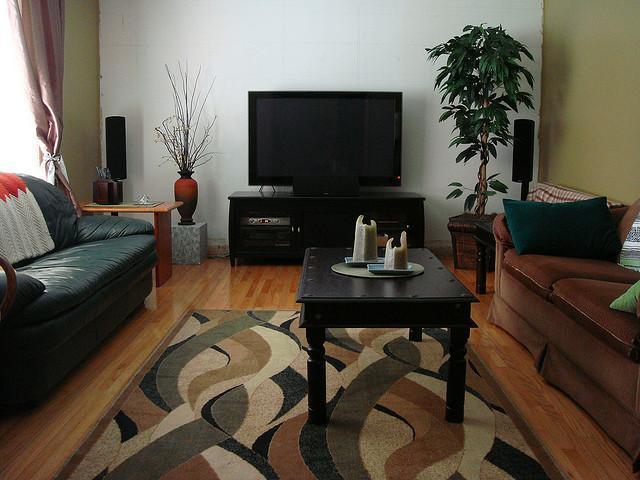How many plants are pictured?
Give a very brief answer. 2. How many potted plants are in the picture?
Give a very brief answer. 2. How many couches are visible?
Give a very brief answer. 2. How many dogs are pictured?
Give a very brief answer. 0. 